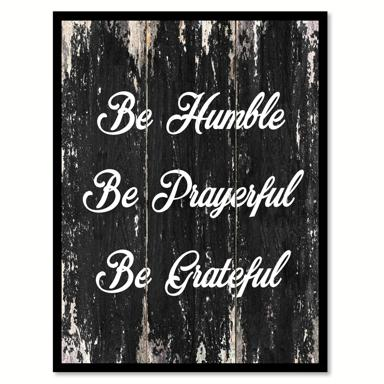What does the background texture imply about the theme of the phrases? The distressed wooden texture of the background suggests resilience and a connection to nature, which complements the humble and grounded virtues the phrases promote. Are there any visual elements that enhance these themes further? Besides the wooden texture, the choice of a monochrome color scheme focuses attention on the simplicity of the message, avoiding any distractions from vibrant colors and reinforcing the theme of humility and thankfulness. 